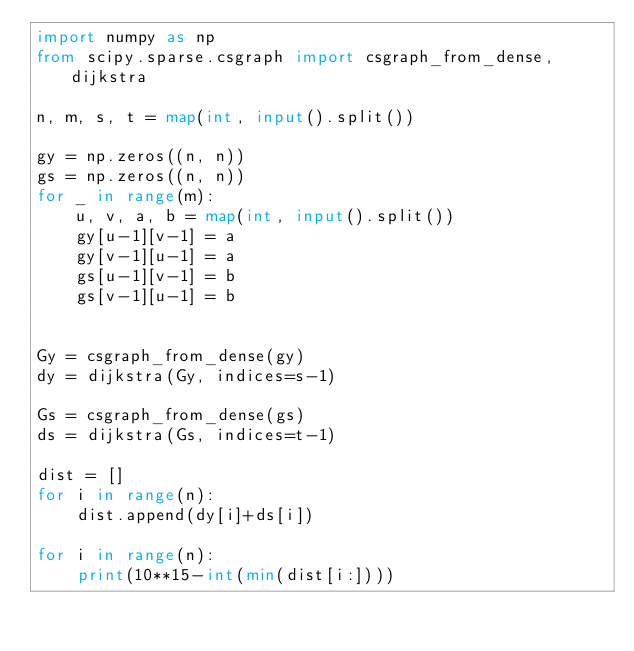<code> <loc_0><loc_0><loc_500><loc_500><_Python_>import numpy as np
from scipy.sparse.csgraph import csgraph_from_dense, dijkstra

n, m, s, t = map(int, input().split())

gy = np.zeros((n, n))
gs = np.zeros((n, n))
for _ in range(m):
    u, v, a, b = map(int, input().split())
    gy[u-1][v-1] = a
    gy[v-1][u-1] = a
    gs[u-1][v-1] = b
    gs[v-1][u-1] = b


Gy = csgraph_from_dense(gy)
dy = dijkstra(Gy, indices=s-1)

Gs = csgraph_from_dense(gs)
ds = dijkstra(Gs, indices=t-1)

dist = []
for i in range(n):
    dist.append(dy[i]+ds[i])

for i in range(n):
    print(10**15-int(min(dist[i:])))
</code> 